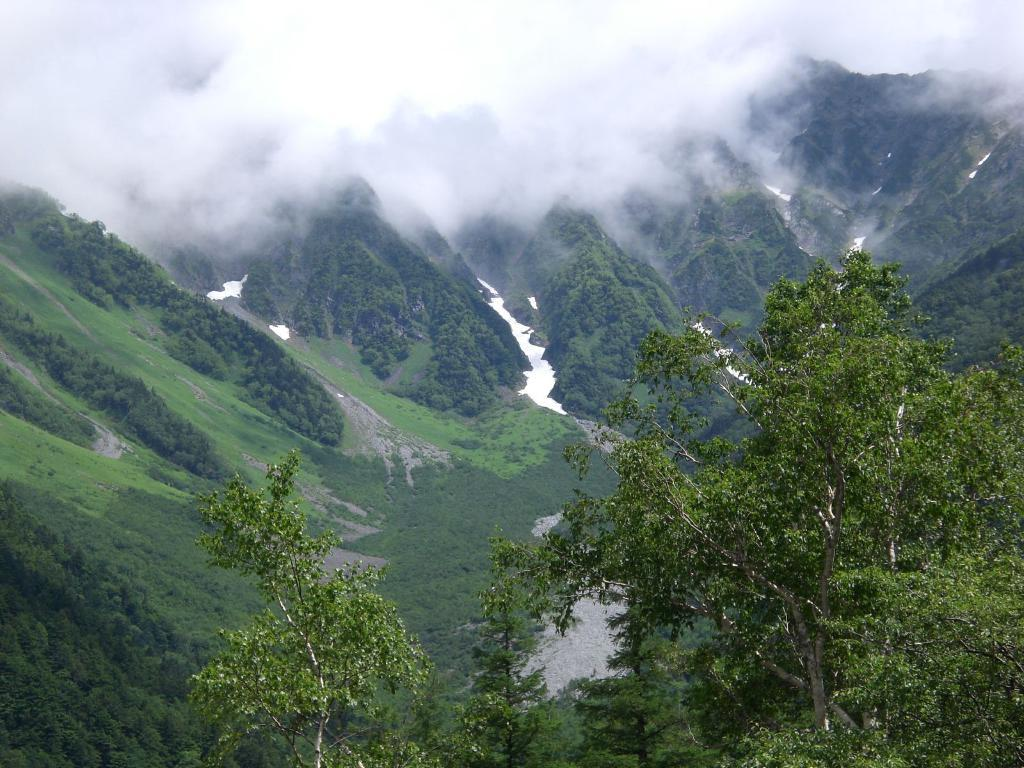What type of vegetation can be seen in the image? There are trees in the image. What geographical feature is visible in the background? There are mountains in the image. What type of ground cover is present in the image? There is grass in the image. What can be seen in the sky in the image? Clouds are present in the sky. What type of reward is hanging from the trees in the image? There is no reward hanging from the trees in the image; it only features trees, mountains, grass, and clouds. What type of land is visible in the image? The image does not specifically show a type of land; it simply features natural elements such as trees, mountains, and grass. 